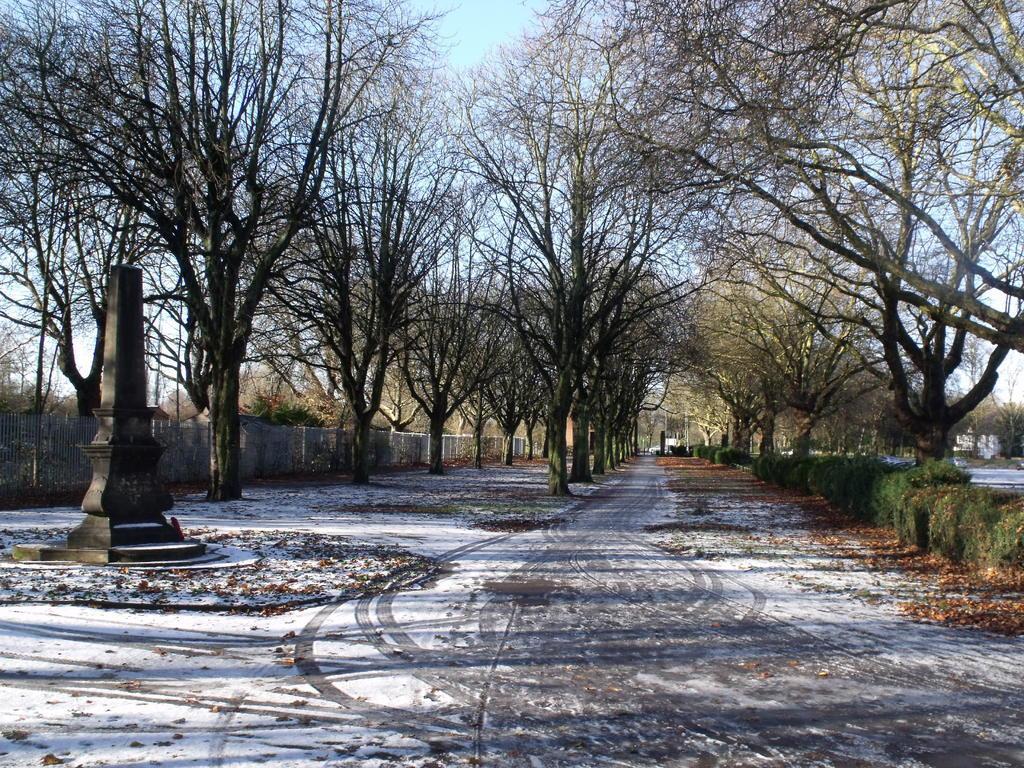Describe this image in one or two sentences. This is an outside view. At the bottom, I can see the ground. On the right side there are few plants. In the background there are many trees. On the left side there is a pillar and also I can see a wall. At the top of the image I can see the sky. 